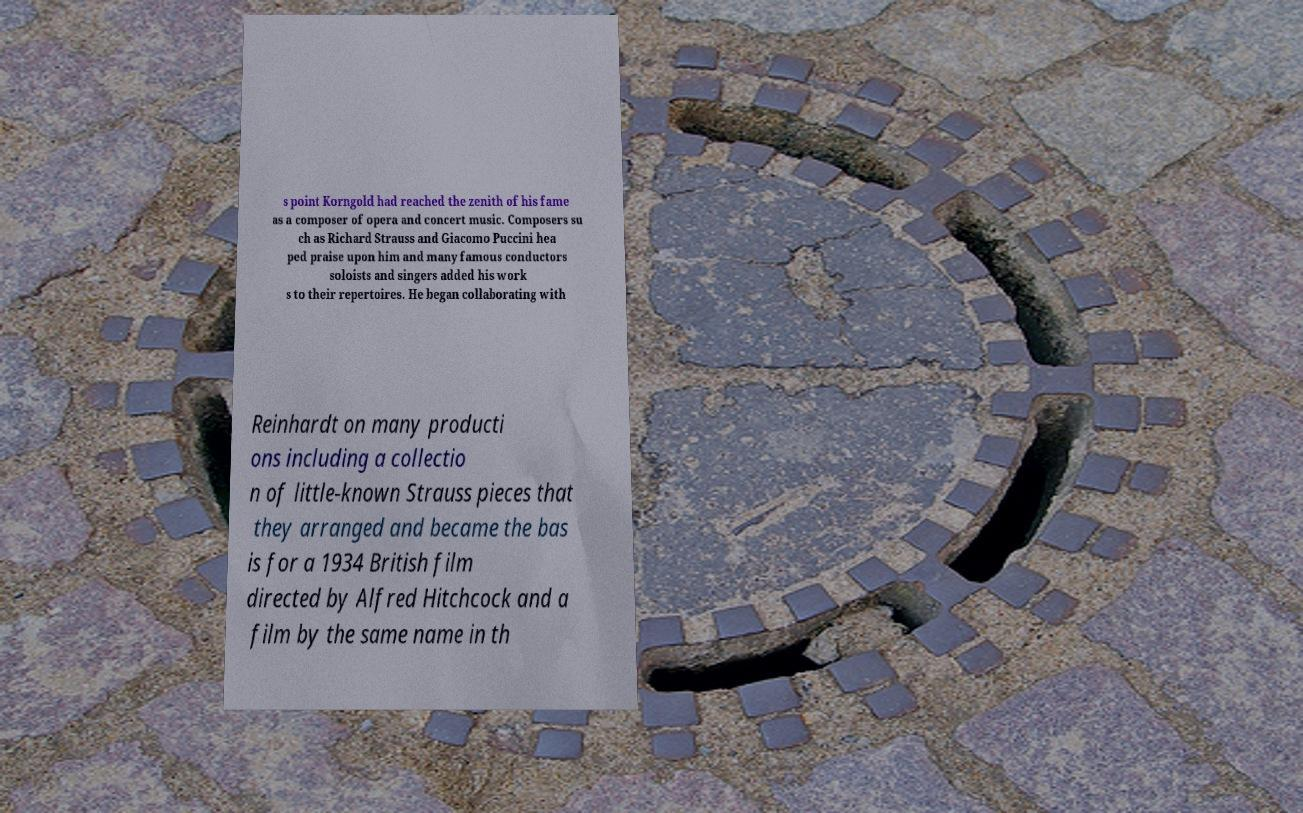I need the written content from this picture converted into text. Can you do that? s point Korngold had reached the zenith of his fame as a composer of opera and concert music. Composers su ch as Richard Strauss and Giacomo Puccini hea ped praise upon him and many famous conductors soloists and singers added his work s to their repertoires. He began collaborating with Reinhardt on many producti ons including a collectio n of little-known Strauss pieces that they arranged and became the bas is for a 1934 British film directed by Alfred Hitchcock and a film by the same name in th 